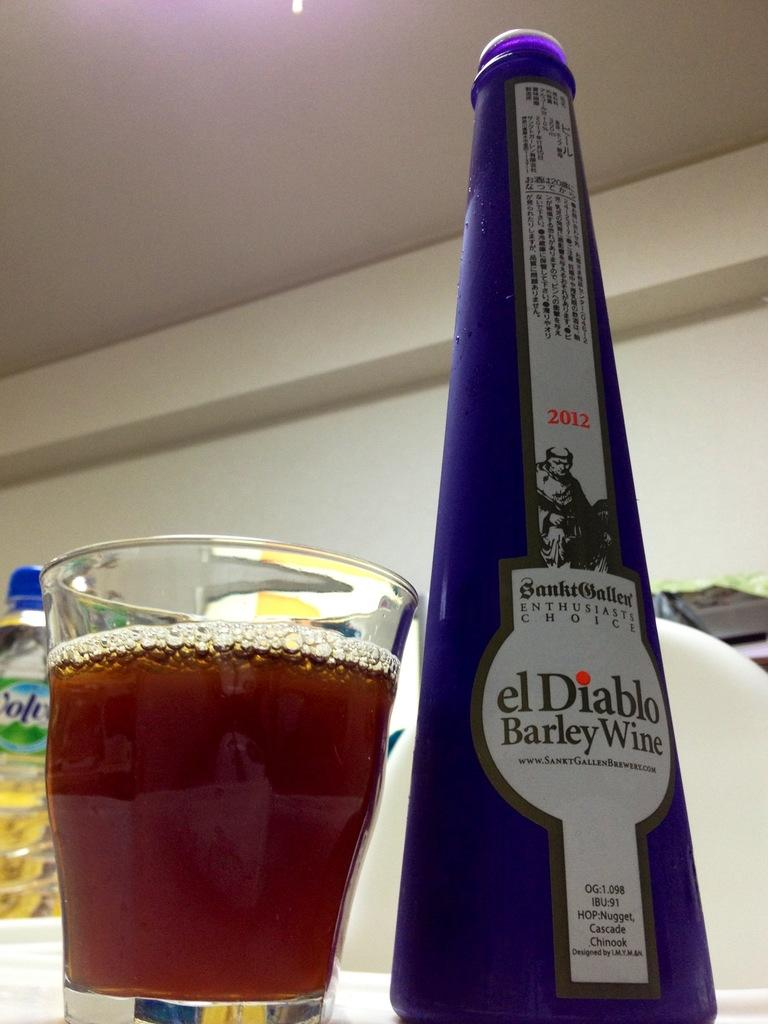<image>
Give a short and clear explanation of the subsequent image. A tall bottle of el Diablo barley wine next to a mostly full glass. 